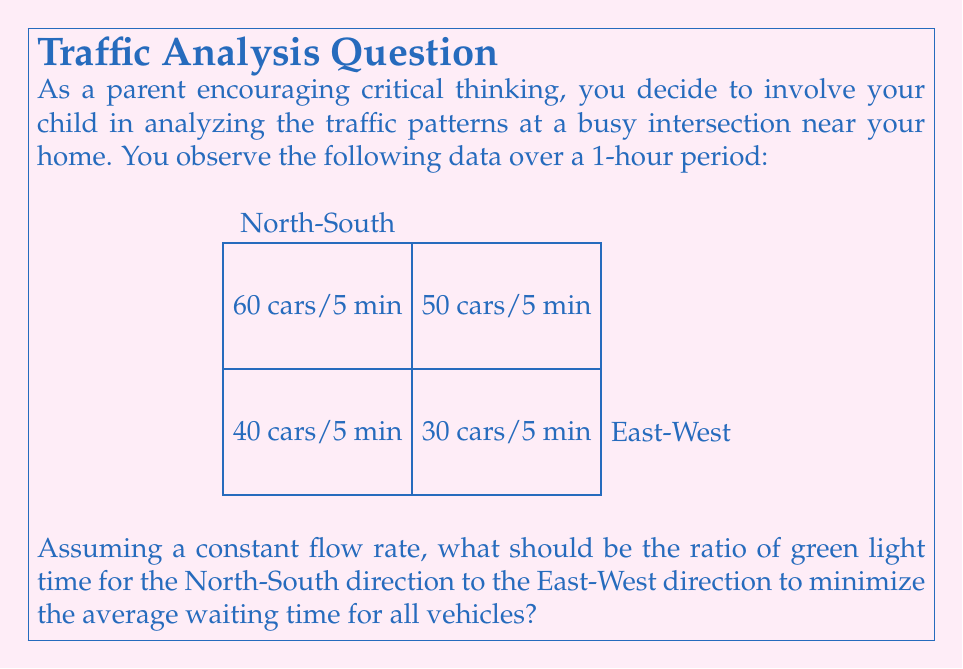Give your solution to this math problem. Let's approach this step-by-step:

1) First, we need to calculate the total number of cars passing through each direction in one hour:

   North-South: $60 + 40 = 100$ cars per 5 minutes
              $100 \times 12 = 1200$ cars per hour

   East-West: $50 + 30 = 80$ cars per 5 minutes
            $80 \times 12 = 960$ cars per hour

2) In traffic light optimization, the principle is to allocate green light time proportional to the traffic flow in each direction. This minimizes the average waiting time for all vehicles.

3) Let's denote the proportion of green light time for North-South direction as $x$. Then, the proportion for East-West direction will be $(1-x)$.

4) To minimize waiting times, these proportions should be equal to the proportion of traffic in each direction:

   $$\frac{x}{1-x} = \frac{1200}{960}$$

5) Simplifying:
   $$\frac{x}{1-x} = \frac{5}{4}$$

6) Solving for $x$:
   $$x = \frac{5}{4}(1-x)$$
   $$x = \frac{5}{4} - \frac{5x}{4}$$
   $$\frac{9x}{4} = \frac{5}{4}$$
   $$x = \frac{5}{9}$$

7) Therefore, the ratio of green light time for North-South to East-West should be:

   $$\frac{5/9}{4/9} = \frac{5}{4} = 1.25:1$$

This ratio ensures that the green light time is proportional to the traffic flow in each direction, minimizing the average waiting time for all vehicles.
Answer: 5:4 